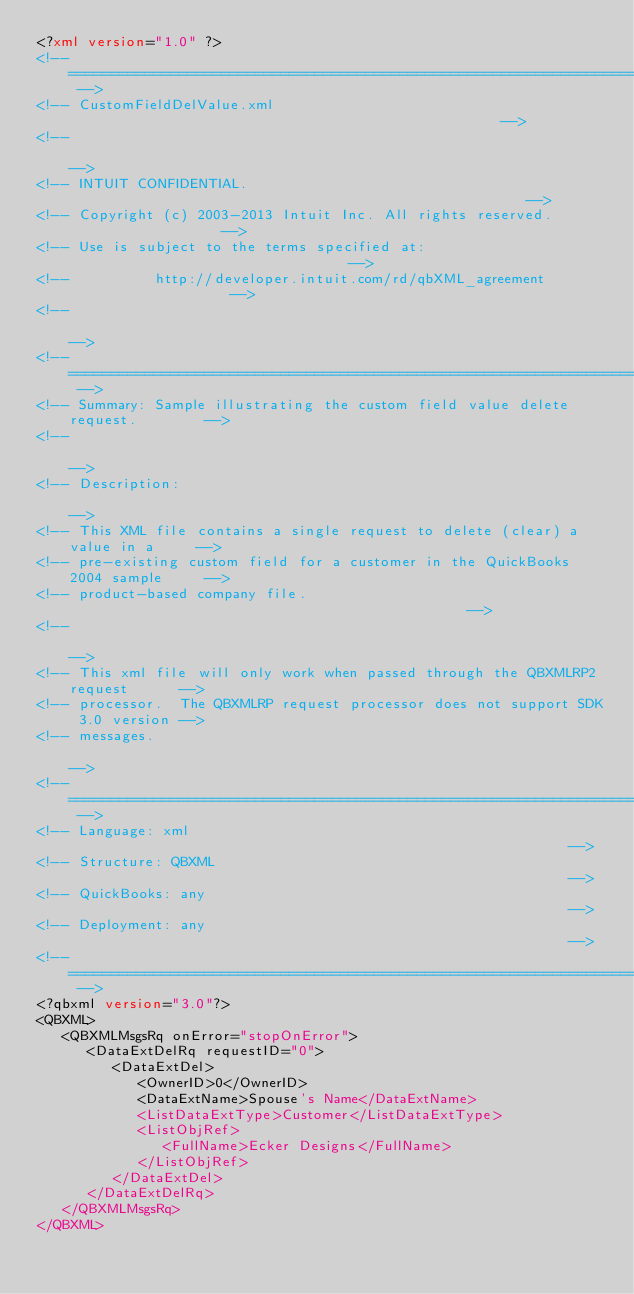<code> <loc_0><loc_0><loc_500><loc_500><_XML_><?xml version="1.0" ?>
<!-- ========================================================================== -->
<!-- CustomFieldDelValue.xml                                                    -->
<!--                                                                            -->
<!-- INTUIT CONFIDENTIAL.                                                       -->
<!-- Copyright (c) 2003-2013 Intuit Inc. All rights reserved.                   -->
<!-- Use is subject to the terms specified at:                                  -->
<!--          http://developer.intuit.com/rd/qbXML_agreement                    -->
<!--                                                                            -->
<!-- ========================================================================== -->
<!-- Summary: Sample illustrating the custom field value delete request.        -->
<!--                                                                            -->
<!-- Description:                                                               -->
<!-- This XML file contains a single request to delete (clear) a value in a     -->
<!-- pre-existing custom field for a customer in the QuickBooks 2004 sample     -->
<!-- product-based company file.                                                -->
<!--                                                                            -->
<!-- This xml file will only work when passed through the QBXMLRP2 request      -->
<!-- processor.  The QBXMLRP request processor does not support SDK 3.0 version -->
<!-- messages.                                                                  -->
<!-- ========================================================================== -->
<!-- Language: xml                                                            -->
<!-- Structure: QBXML                                                            -->
<!-- QuickBooks: any                                                            -->
<!-- Deployment: any                                                            -->
<!-- ========================================================================== -->
<?qbxml version="3.0"?>
<QBXML>
   <QBXMLMsgsRq onError="stopOnError">
      <DataExtDelRq requestID="0">
         <DataExtDel>
            <OwnerID>0</OwnerID>
            <DataExtName>Spouse's Name</DataExtName>
            <ListDataExtType>Customer</ListDataExtType>
            <ListObjRef>
               <FullName>Ecker Designs</FullName>
            </ListObjRef>
         </DataExtDel>
      </DataExtDelRq>
   </QBXMLMsgsRq>
</QBXML>
</code> 